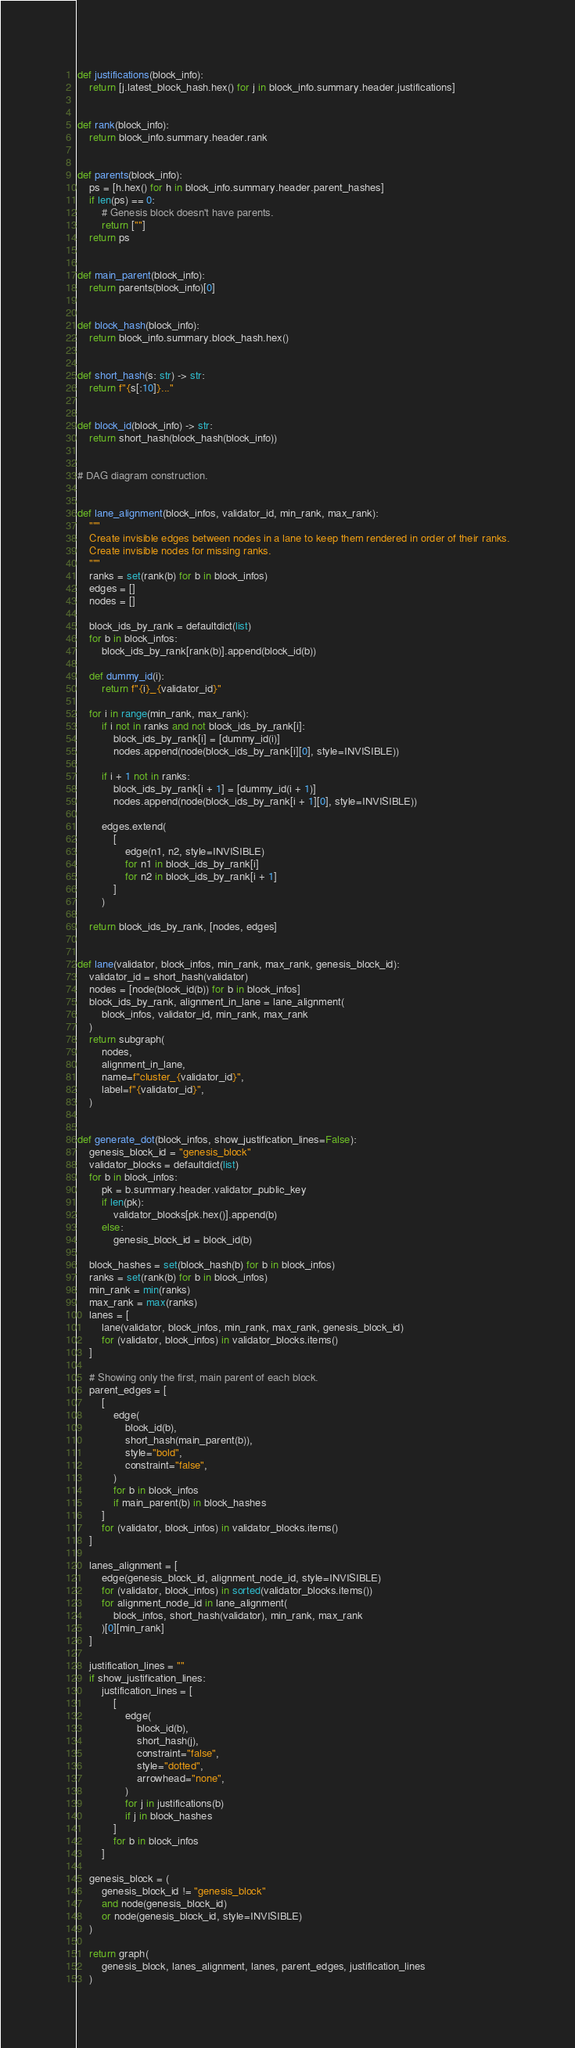Convert code to text. <code><loc_0><loc_0><loc_500><loc_500><_Python_>
def justifications(block_info):
    return [j.latest_block_hash.hex() for j in block_info.summary.header.justifications]


def rank(block_info):
    return block_info.summary.header.rank


def parents(block_info):
    ps = [h.hex() for h in block_info.summary.header.parent_hashes]
    if len(ps) == 0:
        # Genesis block doesn't have parents.
        return [""]
    return ps


def main_parent(block_info):
    return parents(block_info)[0]


def block_hash(block_info):
    return block_info.summary.block_hash.hex()


def short_hash(s: str) -> str:
    return f"{s[:10]}..."


def block_id(block_info) -> str:
    return short_hash(block_hash(block_info))


# DAG diagram construction.


def lane_alignment(block_infos, validator_id, min_rank, max_rank):
    """
    Create invisible edges between nodes in a lane to keep them rendered in order of their ranks.
    Create invisible nodes for missing ranks.
    """
    ranks = set(rank(b) for b in block_infos)
    edges = []
    nodes = []

    block_ids_by_rank = defaultdict(list)
    for b in block_infos:
        block_ids_by_rank[rank(b)].append(block_id(b))

    def dummy_id(i):
        return f"{i}_{validator_id}"

    for i in range(min_rank, max_rank):
        if i not in ranks and not block_ids_by_rank[i]:
            block_ids_by_rank[i] = [dummy_id(i)]
            nodes.append(node(block_ids_by_rank[i][0], style=INVISIBLE))

        if i + 1 not in ranks:
            block_ids_by_rank[i + 1] = [dummy_id(i + 1)]
            nodes.append(node(block_ids_by_rank[i + 1][0], style=INVISIBLE))

        edges.extend(
            [
                edge(n1, n2, style=INVISIBLE)
                for n1 in block_ids_by_rank[i]
                for n2 in block_ids_by_rank[i + 1]
            ]
        )

    return block_ids_by_rank, [nodes, edges]


def lane(validator, block_infos, min_rank, max_rank, genesis_block_id):
    validator_id = short_hash(validator)
    nodes = [node(block_id(b)) for b in block_infos]
    block_ids_by_rank, alignment_in_lane = lane_alignment(
        block_infos, validator_id, min_rank, max_rank
    )
    return subgraph(
        nodes,
        alignment_in_lane,
        name=f"cluster_{validator_id}",
        label=f"{validator_id}",
    )


def generate_dot(block_infos, show_justification_lines=False):
    genesis_block_id = "genesis_block"
    validator_blocks = defaultdict(list)
    for b in block_infos:
        pk = b.summary.header.validator_public_key
        if len(pk):
            validator_blocks[pk.hex()].append(b)
        else:
            genesis_block_id = block_id(b)

    block_hashes = set(block_hash(b) for b in block_infos)
    ranks = set(rank(b) for b in block_infos)
    min_rank = min(ranks)
    max_rank = max(ranks)
    lanes = [
        lane(validator, block_infos, min_rank, max_rank, genesis_block_id)
        for (validator, block_infos) in validator_blocks.items()
    ]

    # Showing only the first, main parent of each block.
    parent_edges = [
        [
            edge(
                block_id(b),
                short_hash(main_parent(b)),
                style="bold",
                constraint="false",
            )
            for b in block_infos
            if main_parent(b) in block_hashes
        ]
        for (validator, block_infos) in validator_blocks.items()
    ]

    lanes_alignment = [
        edge(genesis_block_id, alignment_node_id, style=INVISIBLE)
        for (validator, block_infos) in sorted(validator_blocks.items())
        for alignment_node_id in lane_alignment(
            block_infos, short_hash(validator), min_rank, max_rank
        )[0][min_rank]
    ]

    justification_lines = ""
    if show_justification_lines:
        justification_lines = [
            [
                edge(
                    block_id(b),
                    short_hash(j),
                    constraint="false",
                    style="dotted",
                    arrowhead="none",
                )
                for j in justifications(b)
                if j in block_hashes
            ]
            for b in block_infos
        ]

    genesis_block = (
        genesis_block_id != "genesis_block"
        and node(genesis_block_id)
        or node(genesis_block_id, style=INVISIBLE)
    )

    return graph(
        genesis_block, lanes_alignment, lanes, parent_edges, justification_lines
    )
</code> 